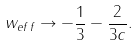Convert formula to latex. <formula><loc_0><loc_0><loc_500><loc_500>w _ { e f f } \rightarrow - \frac { 1 } { 3 } - \frac { 2 } { 3 c } .</formula> 